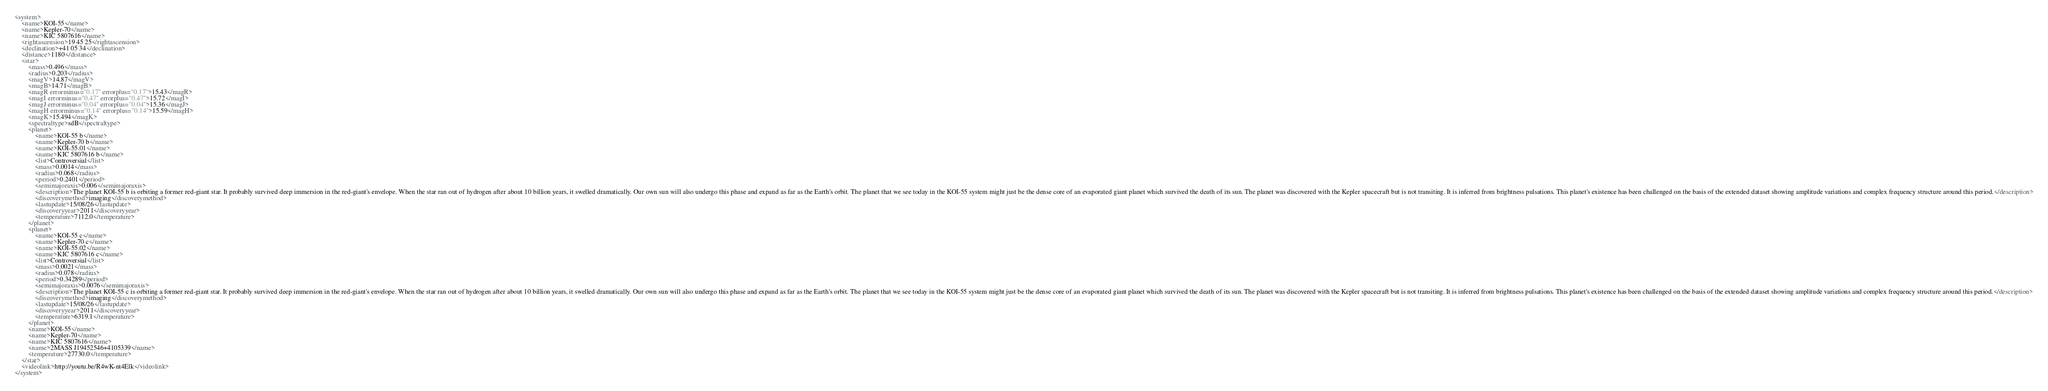<code> <loc_0><loc_0><loc_500><loc_500><_XML_><system>
	<name>KOI-55</name>
	<name>Kepler-70</name>
	<name>KIC 5807616</name>
	<rightascension>19 45 25</rightascension>
	<declination>+41 05 34</declination>
	<distance>1180</distance>
	<star>
		<mass>0.496</mass>
		<radius>0.203</radius>
		<magV>14.87</magV>
		<magB>14.71</magB>
		<magR errorminus="0.17" errorplus="0.17">15.43</magR>
		<magI errorminus="0.47" errorplus="0.47">15.72</magI>
		<magJ errorminus="0.04" errorplus="0.04">15.36</magJ>
		<magH errorminus="0.14" errorplus="0.14">15.59</magH>
		<magK>15.494</magK>
		<spectraltype>sdB</spectraltype>
		<planet>
			<name>KOI-55 b</name>
			<name>Kepler-70 b</name>
			<name>KOI-55.01</name>
			<name>KIC 5807616 b</name>
			<list>Controversial</list>
			<mass>0.0014</mass>
			<radius>0.068</radius>
			<period>0.2401</period>
			<semimajoraxis>0.006</semimajoraxis>
			<description>The planet KOI-55 b is orbiting a former red-giant star. It probably survived deep immersion in the red-giant's envelope. When the star ran out of hydrogen after about 10 billion years, it swelled dramatically. Our own sun will also undergo this phase and expand as far as the Earth's orbit. The planet that we see today in the KOI-55 system might just be the dense core of an evaporated giant planet which survived the death of its sun. The planet was discovered with the Kepler spacecraft but is not transiting. It is inferred from brightness pulsations. This planet's existence has been challenged on the basis of the extended dataset showing amplitude variations and complex frequency structure around this period.</description>
			<discoverymethod>imaging</discoverymethod>
			<lastupdate>15/08/26</lastupdate>
			<discoveryyear>2011</discoveryyear>
			<temperature>7112.0</temperature>
		</planet>
		<planet>
			<name>KOI-55 c</name>
			<name>Kepler-70 c</name>
			<name>KOI-55.02</name>
			<name>KIC 5807616 c</name>
			<list>Controversial</list>
			<mass>0.0021</mass>
			<radius>0.078</radius>
			<period>0.34289</period>
			<semimajoraxis>0.0076</semimajoraxis>
			<description>The planet KOI-55 c is orbiting a former red-giant star. It probably survived deep immersion in the red-giant's envelope. When the star ran out of hydrogen after about 10 billion years, it swelled dramatically. Our own sun will also undergo this phase and expand as far as the Earth's orbit. The planet that we see today in the KOI-55 system might just be the dense core of an evaporated giant planet which survived the death of its sun. The planet was discovered with the Kepler spacecraft but is not transiting. It is inferred from brightness pulsations. This planet's existence has been challenged on the basis of the extended dataset showing amplitude variations and complex frequency structure around this period.</description>
			<discoverymethod>imaging</discoverymethod>
			<lastupdate>15/08/26</lastupdate>
			<discoveryyear>2011</discoveryyear>
			<temperature>6319.1</temperature>
		</planet>
		<name>KOI-55</name>
		<name>Kepler-70</name>
		<name>KIC 5807616</name>
		<name>2MASS J19452546+4105339</name>
		<temperature>27730.0</temperature>
	</star>
	<videolink>http://youtu.be/R4wK-nt4Elk</videolink>
</system>
</code> 